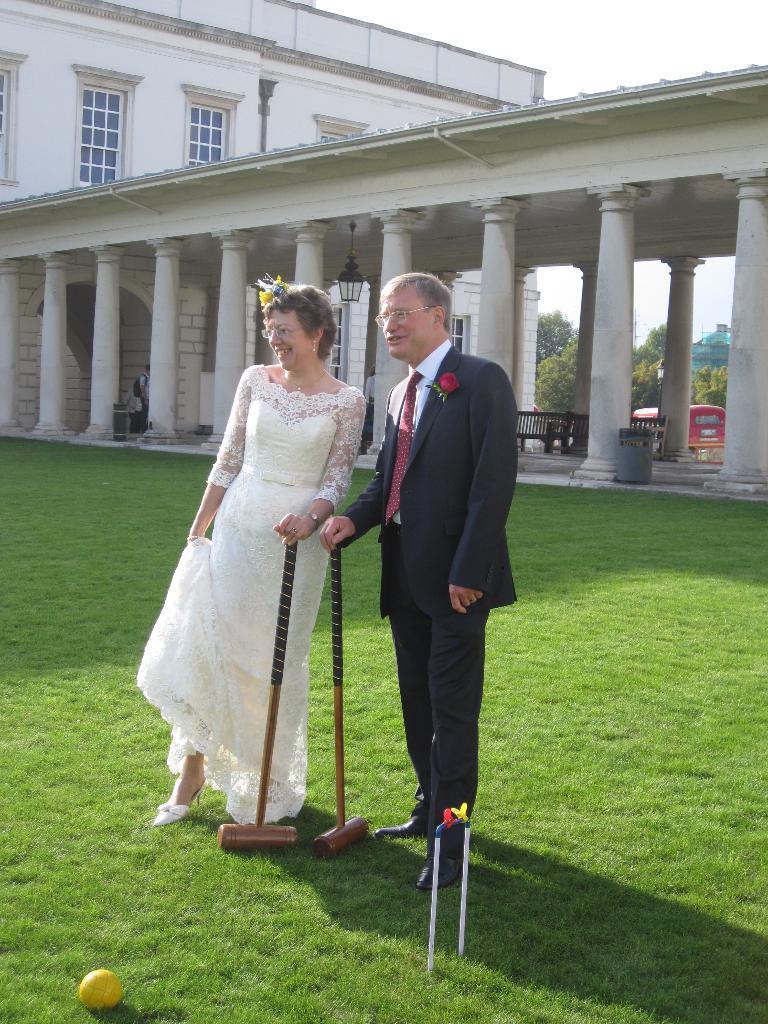Describe this image in one or two sentences. A man is standing, he wore black color coat, trouser. Here a woman is standing, she wore white color dress. This is the building. 